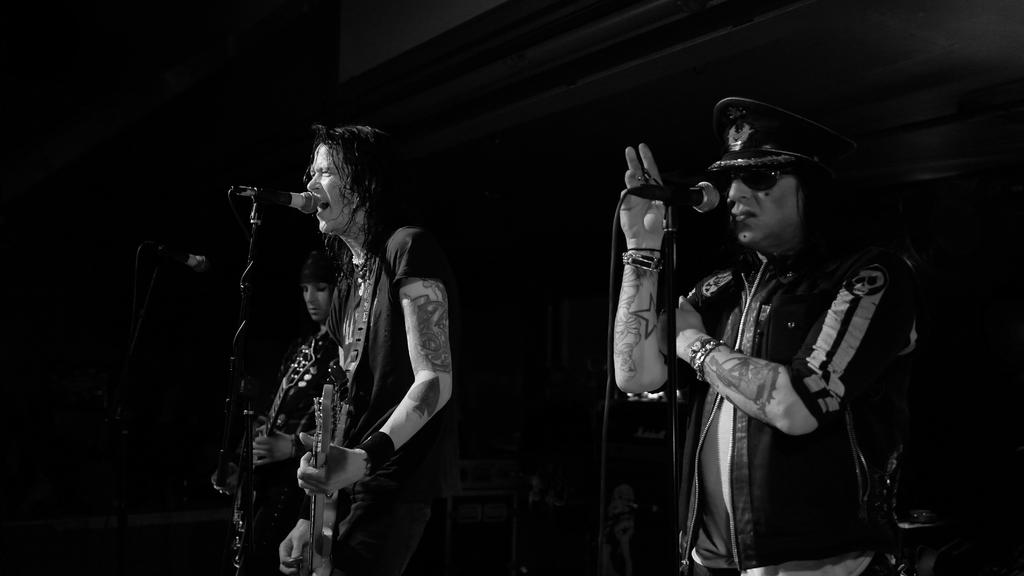How many people are in the image? There are three persons in the image. What are the persons doing in the image? The persons are standing and singing. What object is present in the image that is related to singing? There is a microphone in the image. What type of fish can be seen swimming in the background of the image? There are no fish present in the image; it features three persons standing and singing with a microphone. 